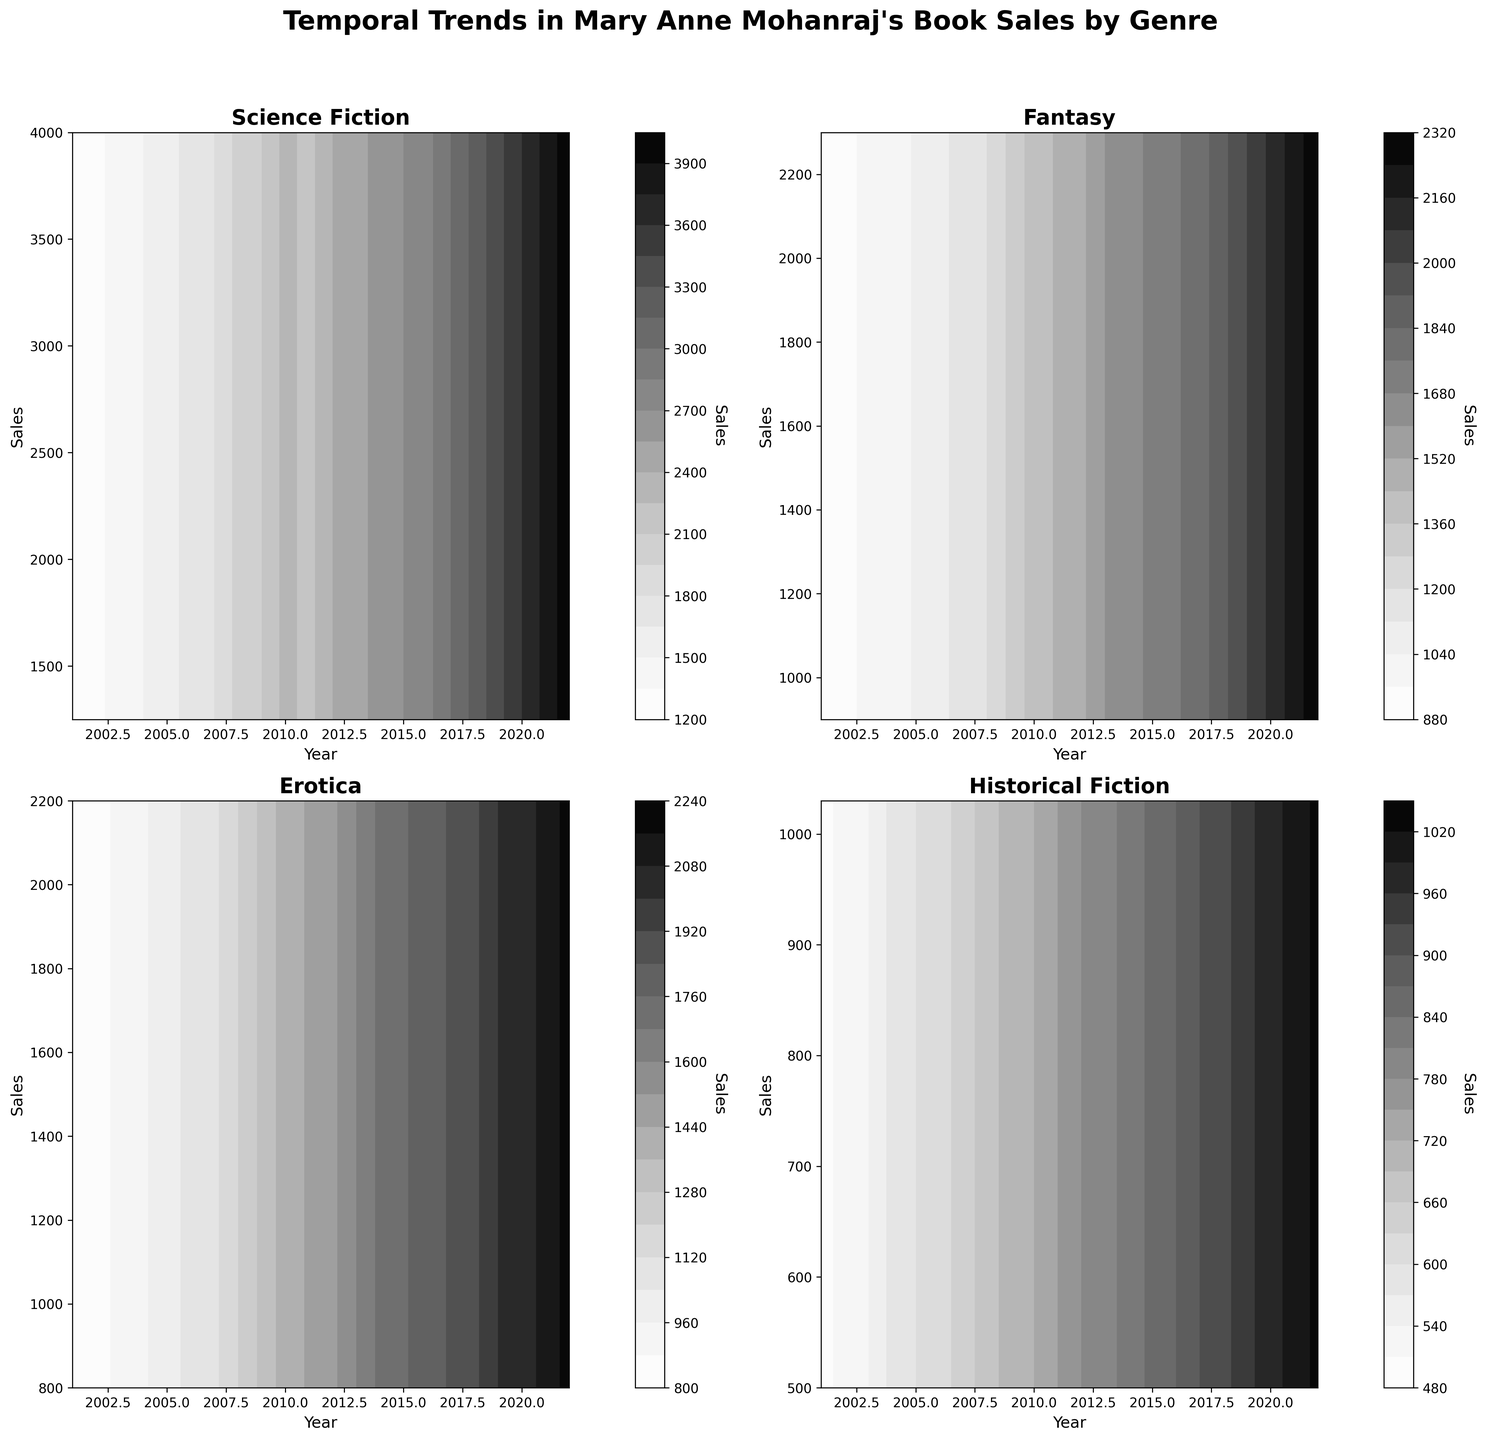How many genres are plotted in the figure? There are four subplots in a 2x2 grid, each representing a different genre. The titles of the subplots indicate these genres.
Answer: Four What is the genre with the highest sales in 2022? By looking at the contours in the subplots, the highest sales for 2022 (though it might not be very precise, it should be clearly distinguishable) are in the subplot for Science Fiction.
Answer: Science Fiction Which genre has the lowest initial sales in 2001? By comparing the bottom-left points of each contour plot, the genre with the lowest sales at the starting year 2001 is Historical Fiction.
Answer: Historical Fiction Did sales for Erotica ever surpass sales for Fantasy? By observing the contour levels for both subplots, one can see that there is an overlap where Erotica's sales match around mid and later years but never really surpass Fantasy when max sales are considered.
Answer: No Which genre shows the most rapid increase in sales over the years? By comparing the slope of the contours across the subplots, Science Fiction shows the steepest gradient, indicating the most rapid increase in sales over the years.
Answer: Science Fiction What is the approximate sales value for Fantasy in the year 2010? In the Fantasy subplot, trace vertically from the 2010 mark to identify the sales value on the sales axis. This corresponds to approximately 1400.
Answer: 1400 Which two genres have nearly parallel sales trends over the plotted years? By examining trends and slope similarities, Erotica and Fantasy have almost parallel trends, indicating similar rates of increase in sales.
Answer: Erotica and Fantasy For which genre is the sales growth most consistent over the years? By looking at the contour intervals' consistency, Historical Fiction exhibits a steady and consistent rise without significant jumps or dips.
Answer: Historical Fiction From 2014 to 2015, which genre experienced the highest absolute increase in sales? By focusing on the 2014-2015 interval in each subplot, the genre that shows the largest gap between sales in the two years is Science Fiction.
Answer: Science Fiction 